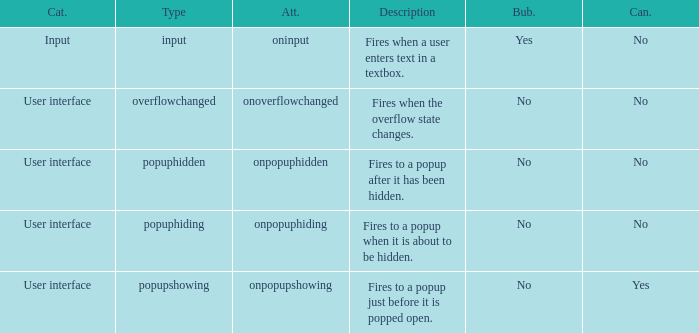 how many bubbles with category being input 1.0. 